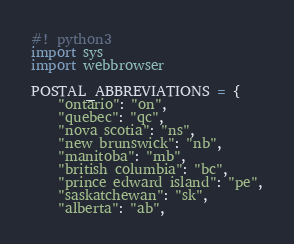<code> <loc_0><loc_0><loc_500><loc_500><_Python_>#! python3
import sys
import webbrowser

POSTAL_ABBREVIATIONS = {
    "ontario": "on",
    "quebec": "qc",
    "nova scotia": "ns",
    "new brunswick": "nb",
    "manitoba": "mb",
    "british columbia": "bc",
    "prince edward island": "pe",
    "saskatchewan": "sk",
    "alberta": "ab",</code> 